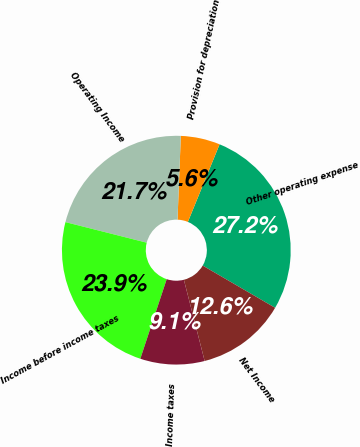Convert chart to OTSL. <chart><loc_0><loc_0><loc_500><loc_500><pie_chart><fcel>Other operating expense<fcel>Provision for depreciation<fcel>Operating Income<fcel>Income before income taxes<fcel>Income taxes<fcel>Net Income<nl><fcel>27.23%<fcel>5.55%<fcel>21.68%<fcel>23.85%<fcel>9.08%<fcel>12.61%<nl></chart> 